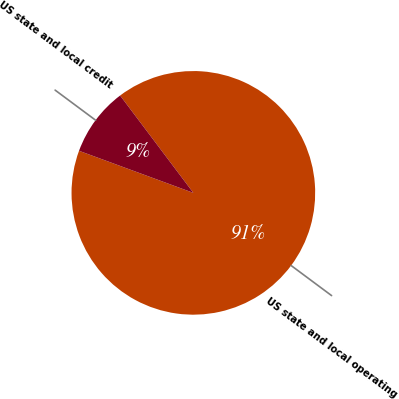<chart> <loc_0><loc_0><loc_500><loc_500><pie_chart><fcel>US state and local operating<fcel>US state and local credit<nl><fcel>90.88%<fcel>9.12%<nl></chart> 